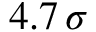Convert formula to latex. <formula><loc_0><loc_0><loc_500><loc_500>4 . 7 \, \sigma</formula> 